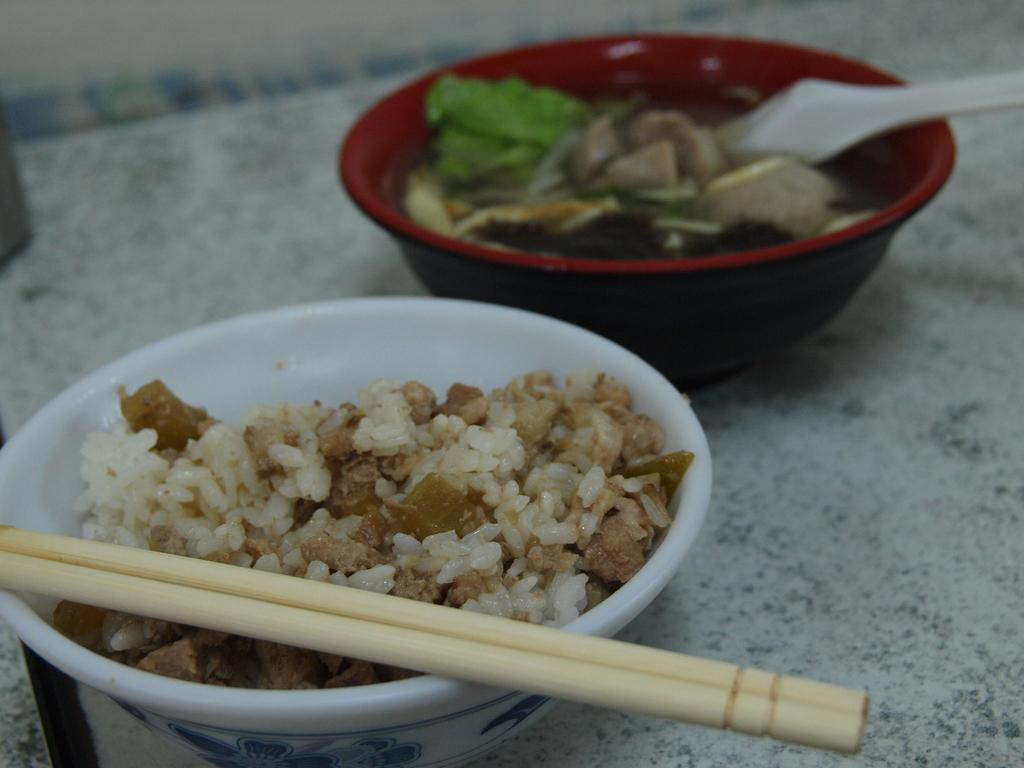What is the primary subject of the image? Food is the main focus of the image. How is the food arranged in the image? The food is presented in a bowl. What utensils are visible in the image? Chopsticks and a spoon are present in the image. What color is the curtain hanging behind the food in the image? There is no curtain present in the image. How many toes can be seen touching the food in the image? There are no toes visible in the image; it only features food, a bowl, chopsticks, and a spoon. 